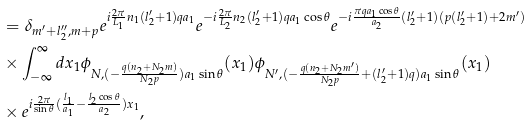Convert formula to latex. <formula><loc_0><loc_0><loc_500><loc_500>& = \delta _ { m ^ { \prime } + l _ { 2 } ^ { \prime \prime } , m + p } e ^ { i \frac { 2 \pi } { L _ { 1 } } n _ { 1 } ( l _ { 2 } ^ { \prime } + 1 ) q a _ { 1 } } e ^ { - i \frac { 2 \pi } { L _ { 2 } } n _ { 2 } ( l _ { 2 } ^ { \prime } + 1 ) q a _ { 1 } \cos \theta } e ^ { - i \frac { \pi q a _ { 1 } \cos \theta } { a _ { 2 } } ( l _ { 2 } ^ { \prime } + 1 ) ( p ( l _ { 2 } ^ { \prime } + 1 ) + 2 m ^ { \prime } ) } \\ & \times \int _ { - \infty } ^ { \infty } d x _ { 1 } \phi _ { N , ( - \frac { q ( n _ { 2 } + N _ { 2 } m ) } { N _ { 2 } p } ) a _ { 1 } \sin \theta } ( x _ { 1 } ) \phi _ { N ^ { \prime } , ( - \frac { q ( n _ { 2 } + N _ { 2 } m ^ { \prime } ) } { N _ { 2 } p } + ( l _ { 2 } ^ { \prime } + 1 ) q ) a _ { 1 } \sin \theta } ( x _ { 1 } ) \\ & \times e ^ { i \frac { 2 \pi } { \sin \theta } ( \frac { l _ { 1 } } { a _ { 1 } } - \frac { l _ { 2 } \cos \theta } { a _ { 2 } } ) x _ { 1 } } ,</formula> 